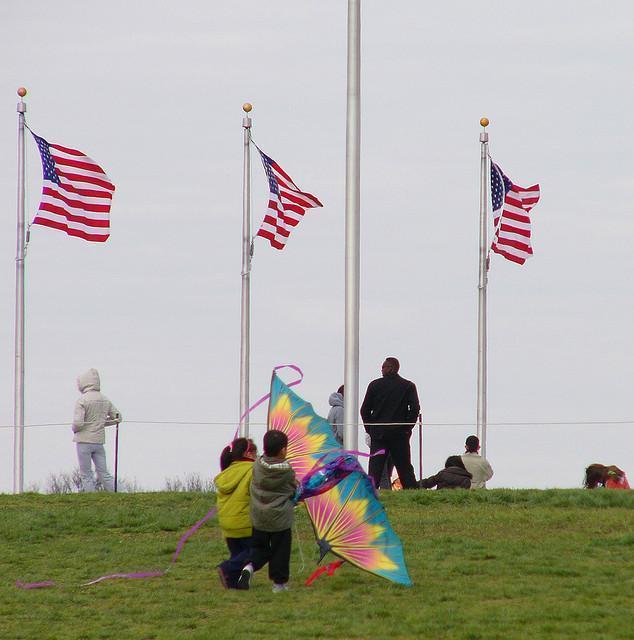How many flagpoles are visible?
Give a very brief answer. 4. How many kites can you see?
Give a very brief answer. 2. How many people are in the photo?
Give a very brief answer. 4. 